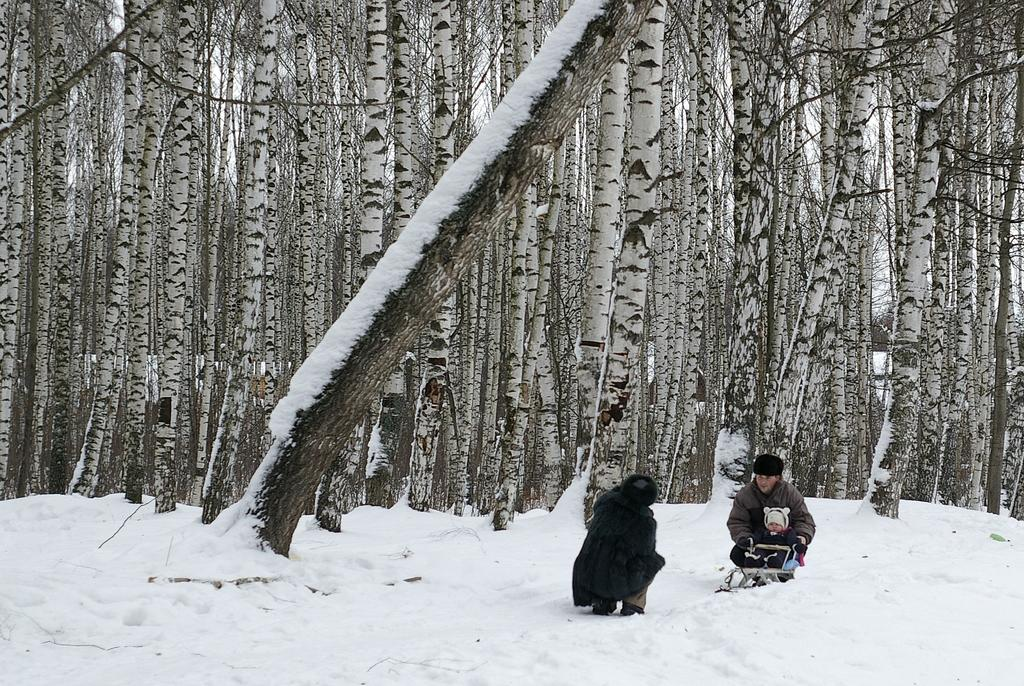How many people are in the foreground of the image? There are three persons in the foreground of the image. What is the location of the persons in the image? The persons are on an ice mountain. What can be seen in the image? There are tree trunks in the background of the image. When was the image taken? The image was taken during the day. Can you see a giraffe touching the tree trunks in the image? There is no giraffe present in the image, and therefore it cannot be touching the tree trunks. 